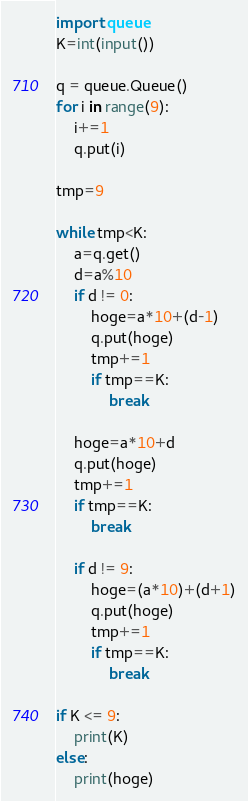<code> <loc_0><loc_0><loc_500><loc_500><_Python_>import queue
K=int(input())

q = queue.Queue()
for i in range(9):
    i+=1
    q.put(i)

tmp=9

while tmp<K:
    a=q.get()
    d=a%10
    if d != 0:
        hoge=a*10+(d-1)
        q.put(hoge)
        tmp+=1
        if tmp==K:
            break
    
    hoge=a*10+d
    q.put(hoge)
    tmp+=1
    if tmp==K:
        break

    if d != 9:
        hoge=(a*10)+(d+1)
        q.put(hoge)
        tmp+=1
        if tmp==K:
            break

if K <= 9:
    print(K)
else:
    print(hoge)</code> 